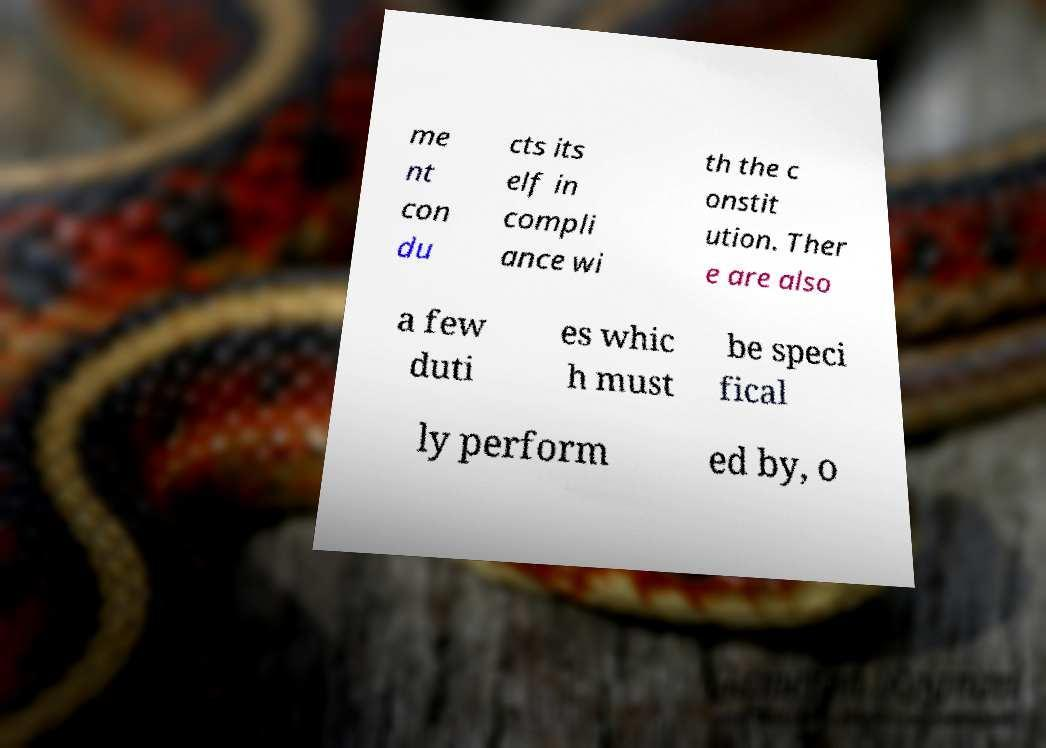Can you read and provide the text displayed in the image?This photo seems to have some interesting text. Can you extract and type it out for me? me nt con du cts its elf in compli ance wi th the c onstit ution. Ther e are also a few duti es whic h must be speci fical ly perform ed by, o 